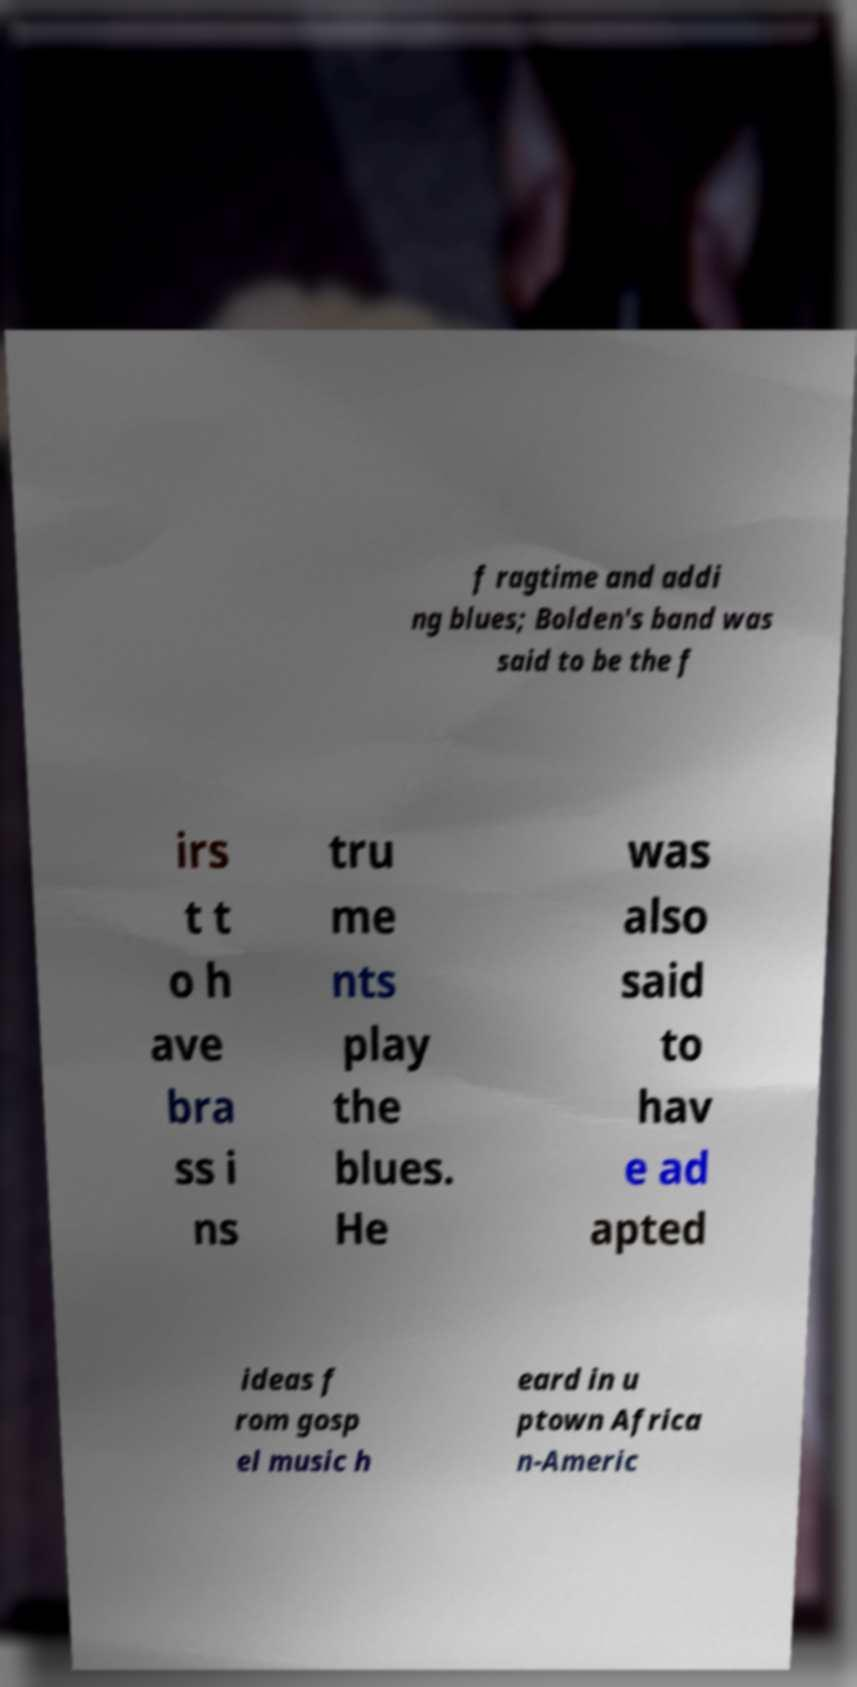Can you read and provide the text displayed in the image?This photo seems to have some interesting text. Can you extract and type it out for me? f ragtime and addi ng blues; Bolden's band was said to be the f irs t t o h ave bra ss i ns tru me nts play the blues. He was also said to hav e ad apted ideas f rom gosp el music h eard in u ptown Africa n-Americ 